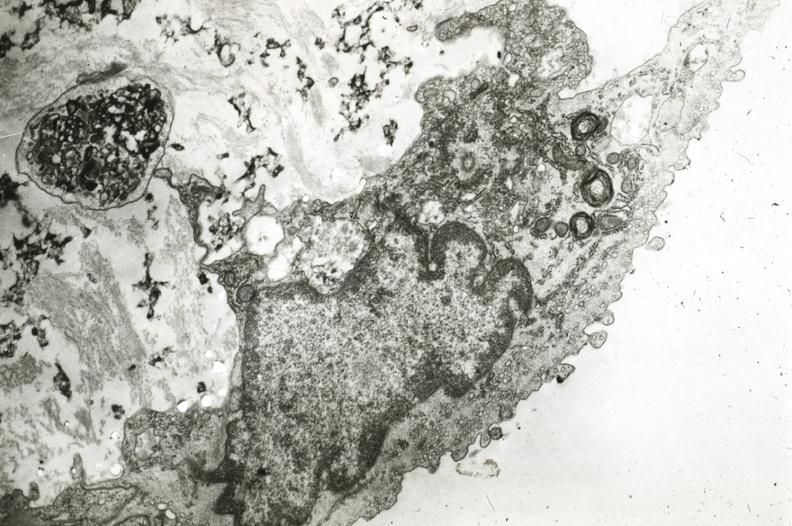s cardiovascular present?
Answer the question using a single word or phrase. Yes 